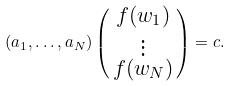<formula> <loc_0><loc_0><loc_500><loc_500>( a _ { 1 } , \dots , a _ { N } ) \left ( \begin{smallmatrix} f ( w _ { 1 } ) \\ \vdots \\ f ( w _ { N } ) \end{smallmatrix} \right ) = c .</formula> 